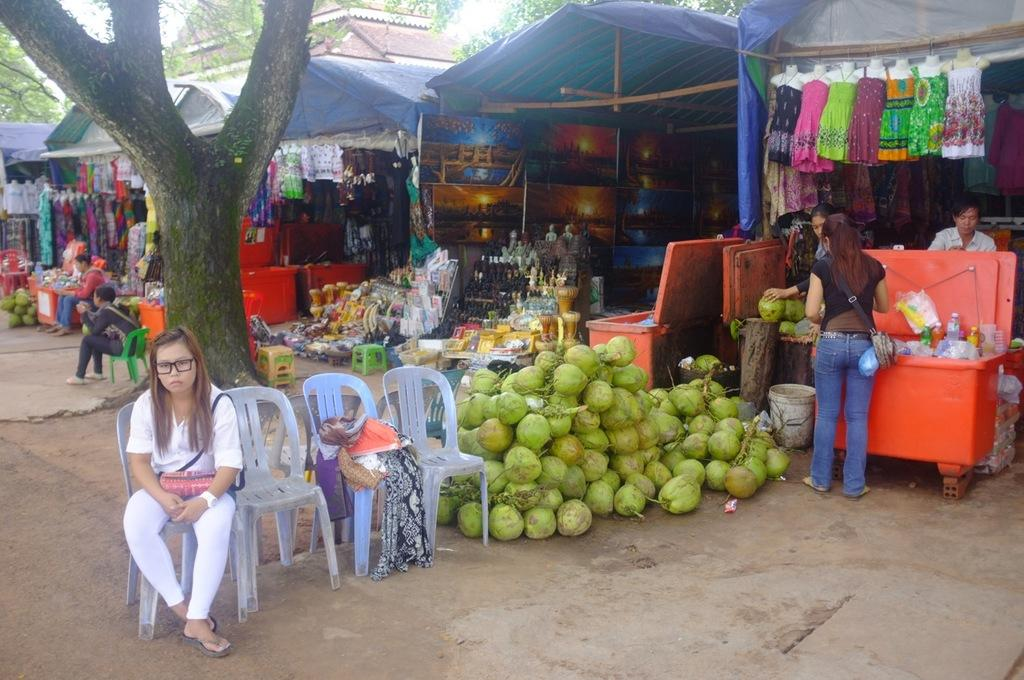Who or what can be seen in the image? There are people in the image. What is visible in the background of the image? There are stores in the background of the image. Can you describe any natural elements in the image? There is a tree in the image. What object is on the floor in the image? There is a coconut on the floor. What is the woman in the image doing? A woman is sitting on a chair. What color is the sweater worn by the moon in the image? There is no moon present in the image, nor is there any mention of a sweater. 